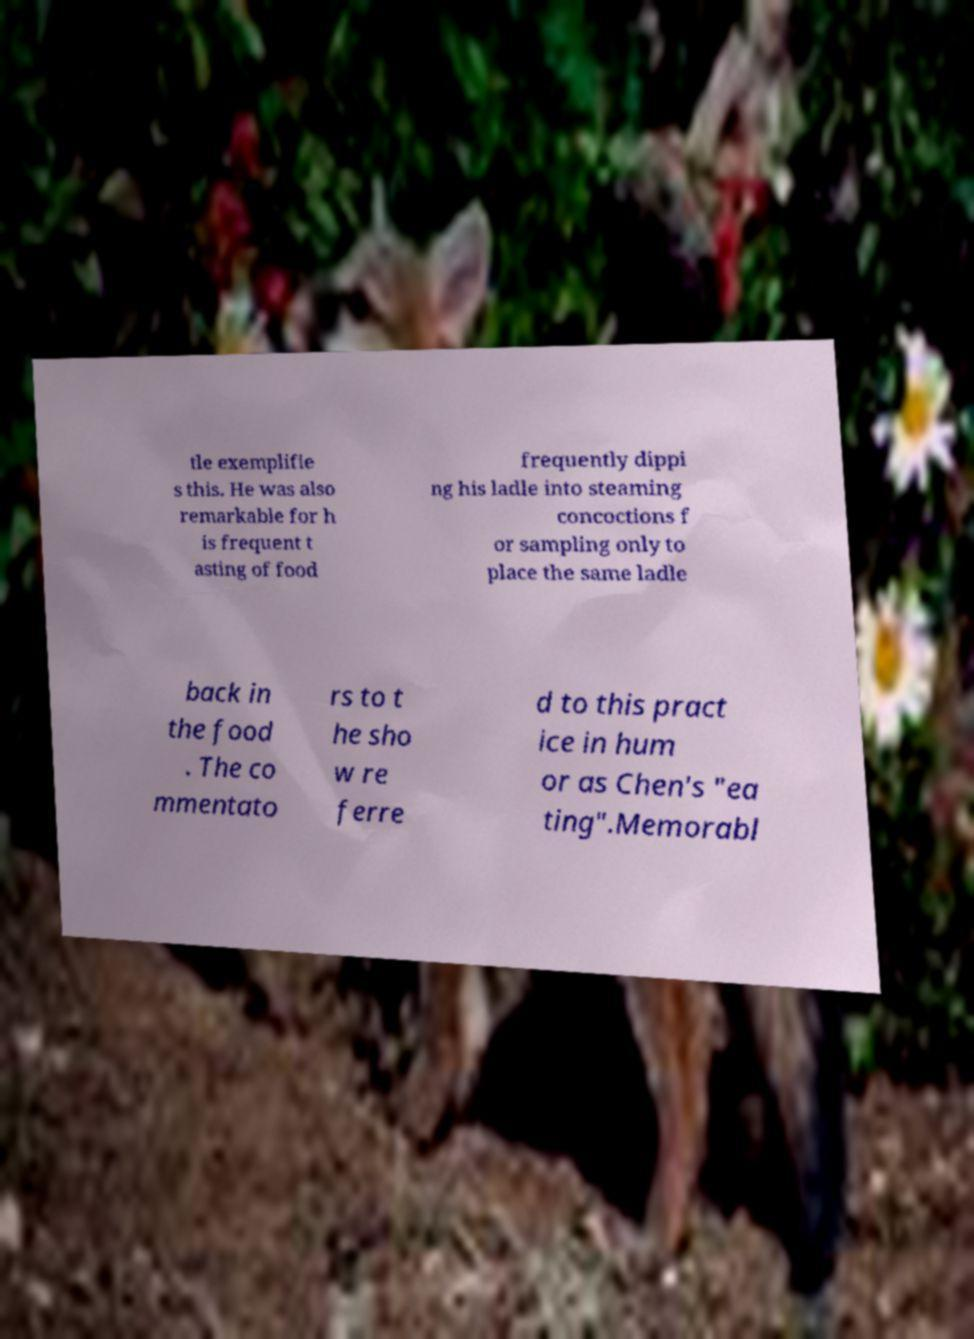I need the written content from this picture converted into text. Can you do that? tle exemplifie s this. He was also remarkable for h is frequent t asting of food frequently dippi ng his ladle into steaming concoctions f or sampling only to place the same ladle back in the food . The co mmentato rs to t he sho w re ferre d to this pract ice in hum or as Chen's "ea ting".Memorabl 